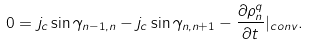<formula> <loc_0><loc_0><loc_500><loc_500>0 = j _ { c } \sin \gamma _ { n - 1 , n } - j _ { c } \sin \gamma _ { n , n + 1 } - \frac { \partial \rho _ { n } ^ { q } } { \partial t } | _ { c o n v } .</formula> 